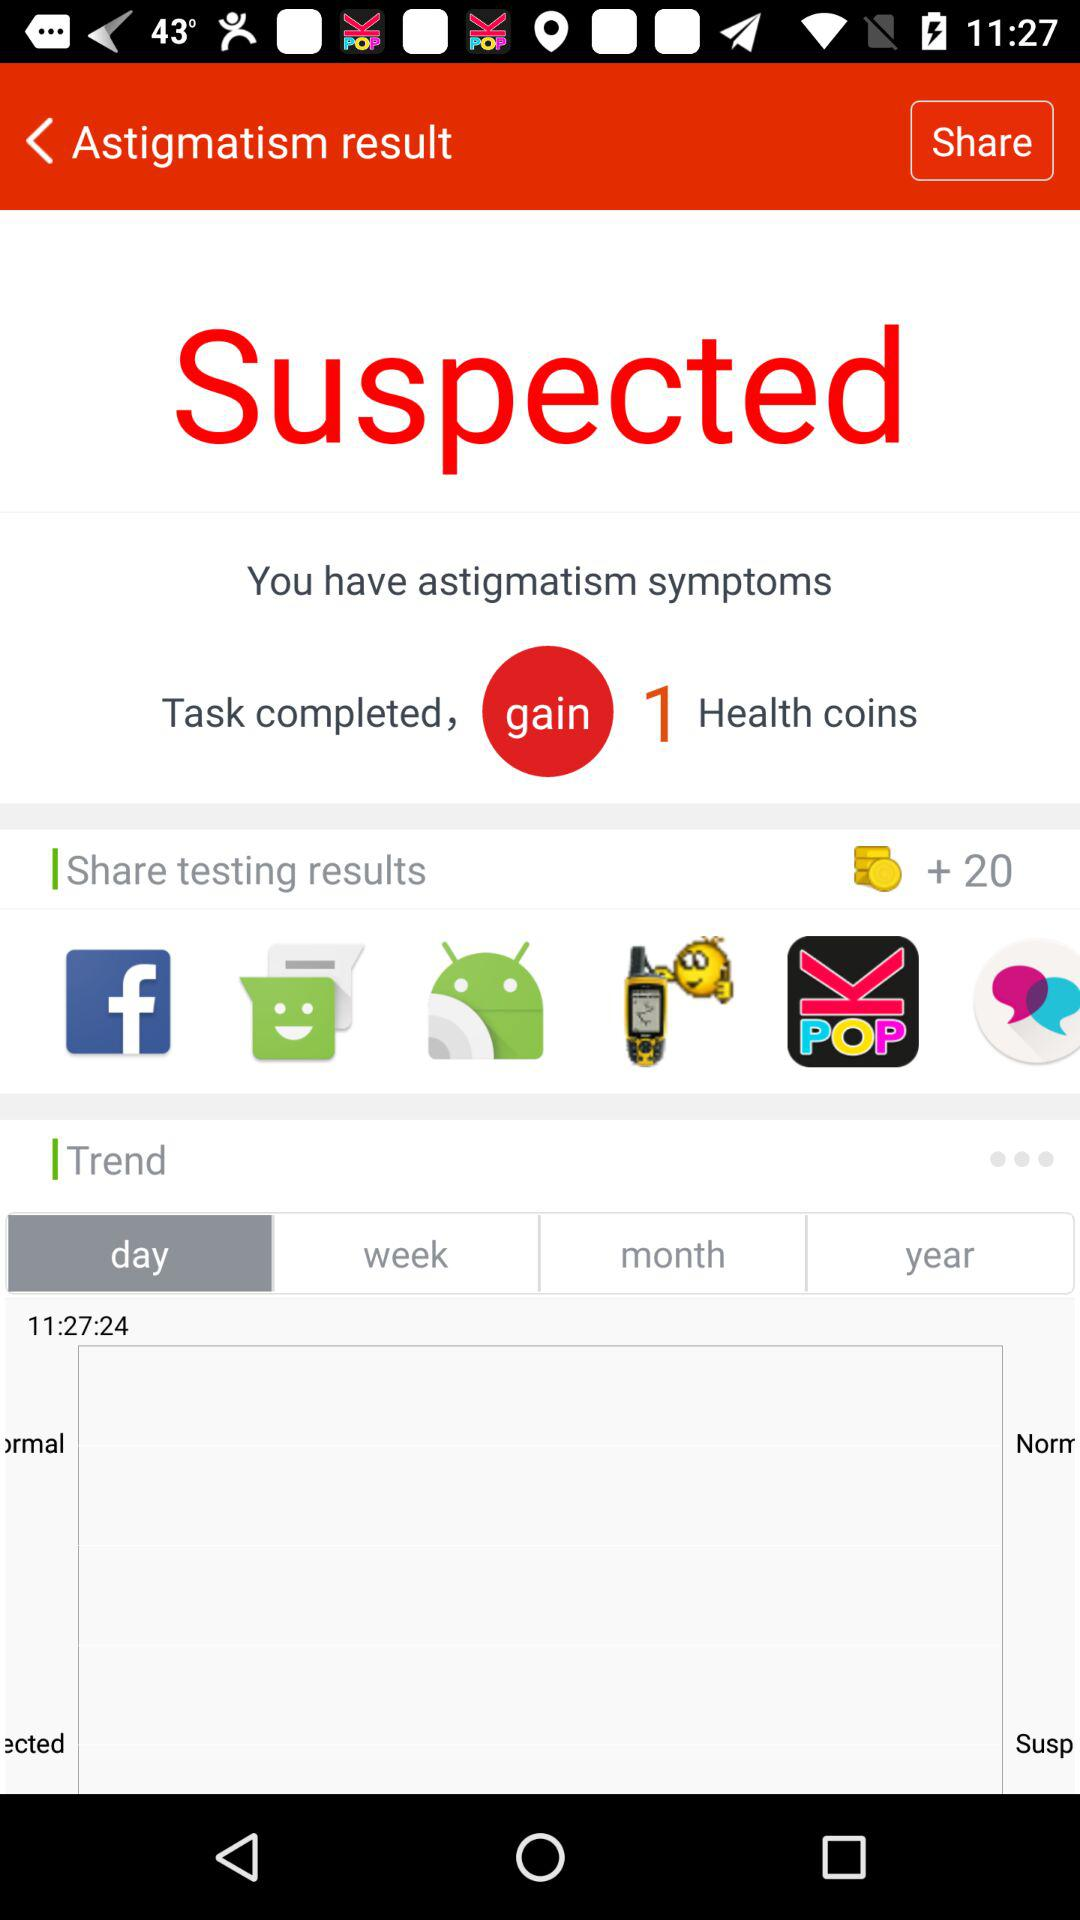How many health coins are gained after task completion? There is one health coin gained after task completion. 